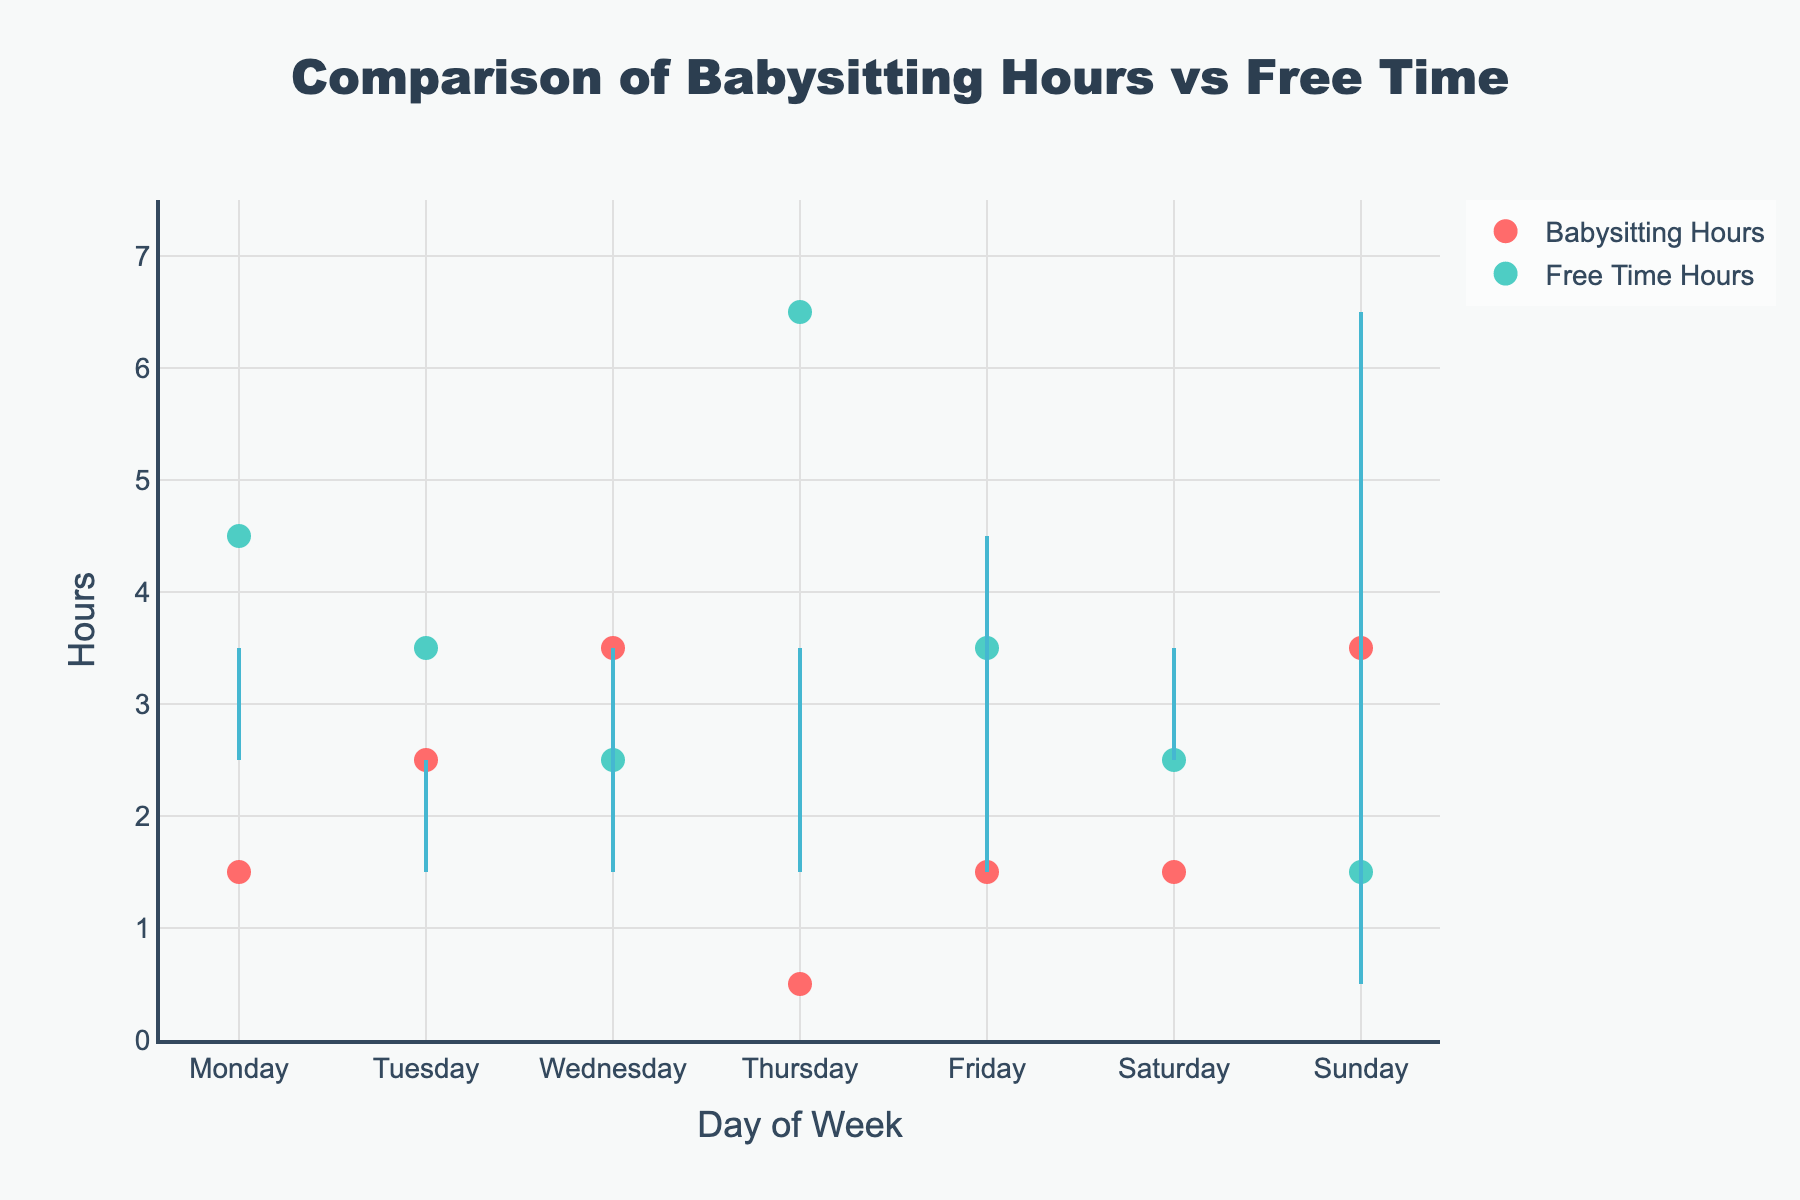What is the title of the plot? The answer is at the top of the plot.
Answer: Comparison of Babysitting Hours vs Free Time Which day has the highest average free time hours? Look at the markers and pick the day with the highest y-value for Free Time Hours.
Answer: Sunday Which day shows the smallest difference between babysitting hours and free time hours? Compare the length of the lines connecting the babysitting and free time hours for each day.
Answer: Monday How many days have higher average free time hours than babysitting hours? Count the days where the Free Time Hours marker is higher on the y-axis than the Babysitting Hours marker.
Answer: Five (Monday, Thursday, Friday, Saturday, Sunday) Which day has the lowest average babysitting hours? Look at the markers and pick the day with the lowest y-value for Babysitting Hours.
Answer: Sunday What are the average babysitting and free time hours on Wednesday? Locate Wednesday on the x-axis and read off the y-values for both Babysitting Hours and Free Time Hours.
Answer: Babysitting: 3.5, Free Time: 1.5 Among all the days, which one has the most balanced hours between babysitting and free time? Find the day where the markers for Babysitting Hours and Free Time Hours are closest in y-value.
Answer: Saturday What is the total average free time hours from Monday to Wednesday? Add the average Free Time Hours for Monday, Tuesday, and Wednesday, then sum them up.
Answer: 3 + 2.5 + 1.5 = 7 How does the average babysitting hours on Friday compare to Thursday? Compare the y-values of Babysitting Hours markers between Friday and Thursday.
Answer: Friday has 1.5 hours greater than Thursday On which day is the average babysitting hours equal to average free time hours? Identify a day where the markers for both Babysitting Hours and Free Time Hours have the same y-value.
Answer: Saturday 